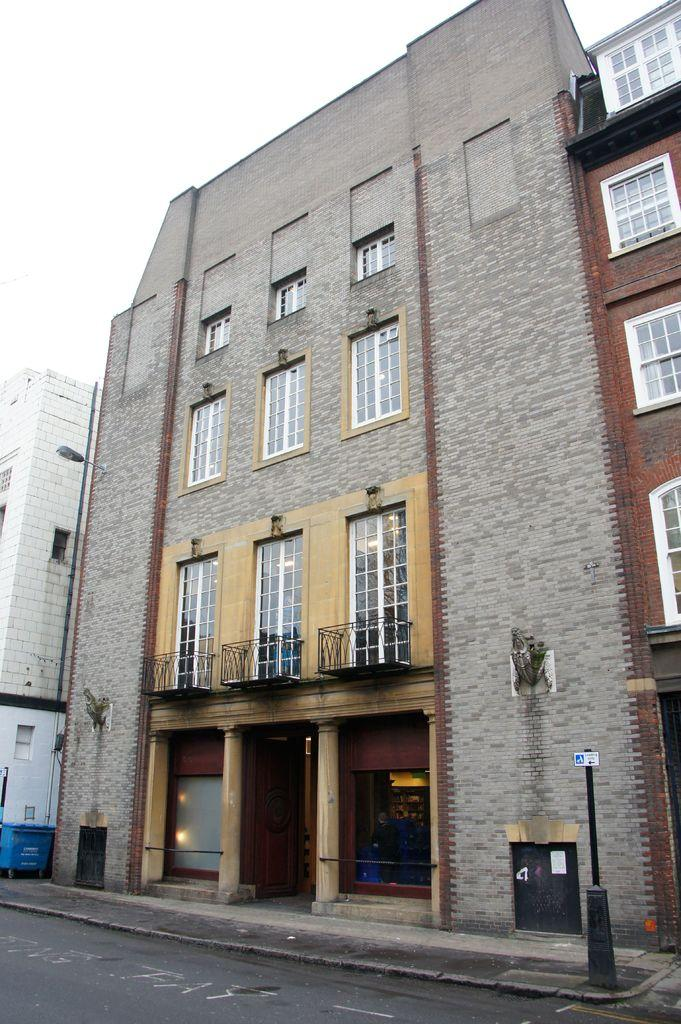What type of structures are visible in the image? There are buildings in the image. What feature can be seen on the buildings? The buildings have windows with glasses. What object is present on the walkway? There is a pole on the walkway. What is the condition of the sky in the image? The sky is clear in the image. What type of picture is the boy holding in the image? There is no boy or picture present in the image; it only features buildings, windows, a pole, and the sky. What shape is the boy's toy in the image? There is no boy or toy present in the image. 